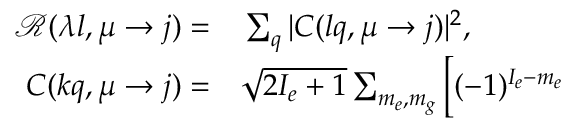Convert formula to latex. <formula><loc_0><loc_0><loc_500><loc_500>\begin{array} { r l } { \mathcal { R } ( \lambda l , \mu \to j ) = } & \sum _ { q } | C ( l q , \mu \to j ) | ^ { 2 } , } \\ { C ( k q , \mu \to j ) = } & \sqrt { 2 I _ { e } + 1 } \sum _ { m _ { e } , m _ { g } } \Big [ ( - 1 ) ^ { I _ { e } - m _ { e } } } \end{array}</formula> 